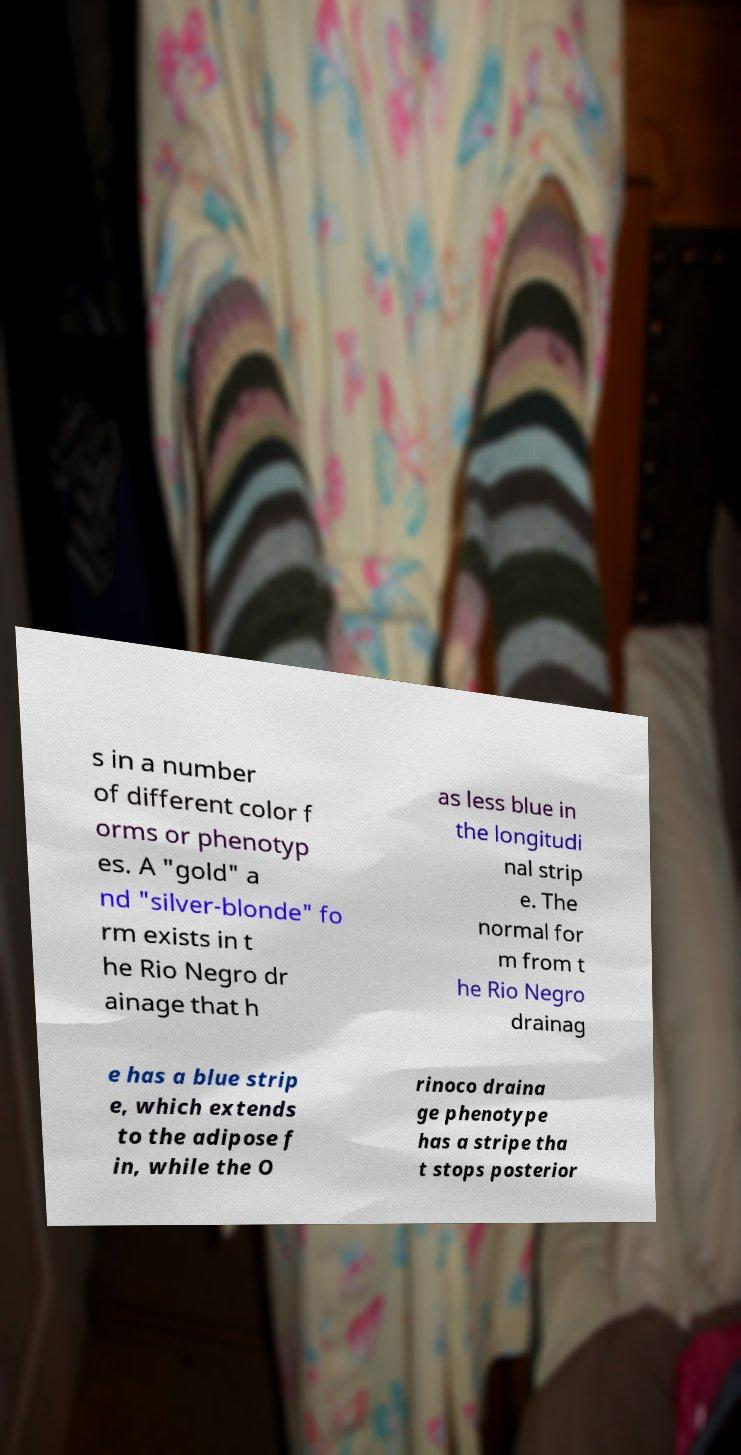There's text embedded in this image that I need extracted. Can you transcribe it verbatim? s in a number of different color f orms or phenotyp es. A "gold" a nd "silver-blonde" fo rm exists in t he Rio Negro dr ainage that h as less blue in the longitudi nal strip e. The normal for m from t he Rio Negro drainag e has a blue strip e, which extends to the adipose f in, while the O rinoco draina ge phenotype has a stripe tha t stops posterior 